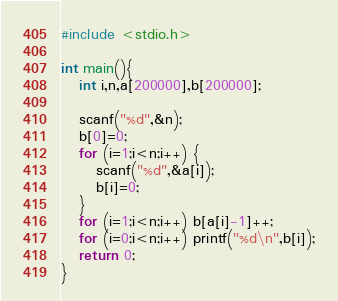<code> <loc_0><loc_0><loc_500><loc_500><_C_>#include <stdio.h>

int main(){
   int i,n,a[200000],b[200000];

   scanf("%d",&n);
   b[0]=0;
   for (i=1;i<n;i++) {
      scanf("%d",&a[i]);
      b[i]=0;
   }
   for (i=1;i<n;i++) b[a[i]-1]++;
   for (i=0;i<n;i++) printf("%d\n",b[i]);
   return 0;
}
</code> 